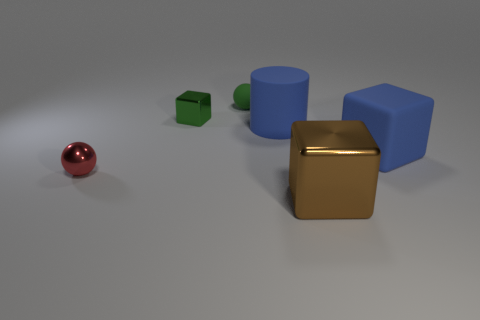How many other things are made of the same material as the large cylinder?
Offer a very short reply. 2. What number of red things are either small metallic things or big metallic things?
Offer a terse response. 1. What size is the metallic cube that is the same color as the tiny matte object?
Your answer should be compact. Small. How many tiny spheres are in front of the tiny green metal object?
Ensure brevity in your answer.  1. What is the size of the metallic block that is behind the big thing that is in front of the thing that is to the right of the big metal object?
Give a very brief answer. Small. Is there a large blue block that is on the left side of the metal block in front of the big blue matte object that is to the right of the big blue rubber cylinder?
Keep it short and to the point. No. Are there more small blue things than small green cubes?
Offer a terse response. No. The small metal object behind the big blue cube is what color?
Make the answer very short. Green. Are there more green objects right of the green metal object than big brown shiny blocks?
Your answer should be very brief. No. Does the large brown block have the same material as the big blue cylinder?
Your answer should be very brief. No. 